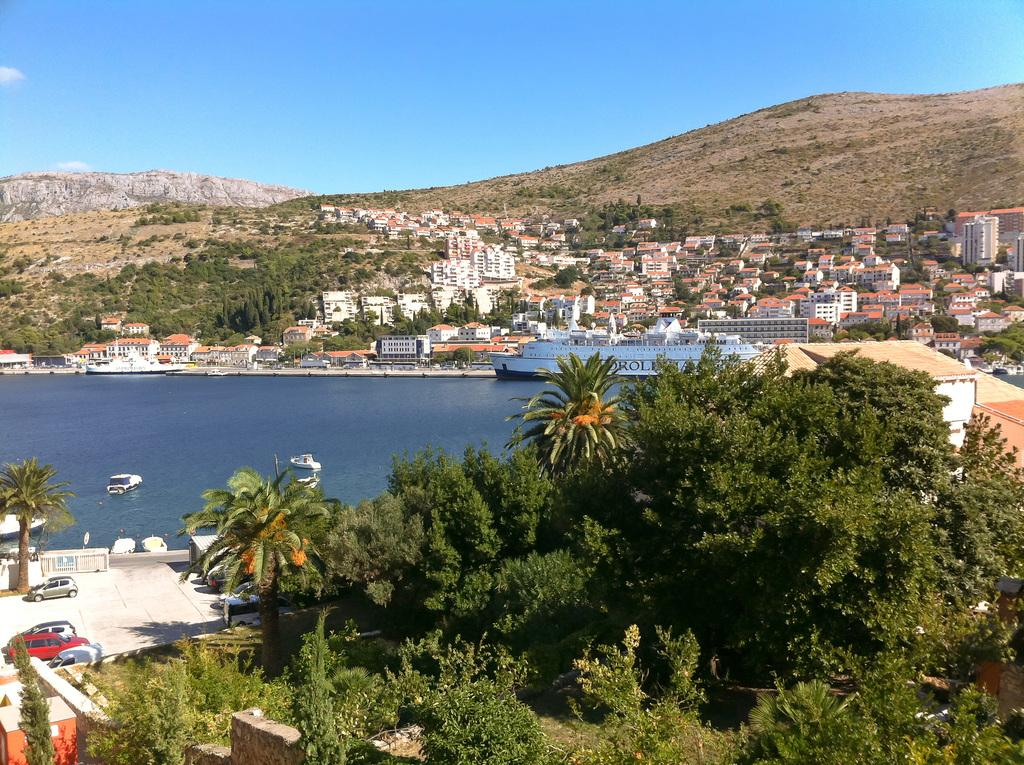What type of watercraft can be seen in the image? There is a ship and boats in the image. What is the primary setting of the image? There is water visible in the image, along with plants, trees, vehicles, buildings, and a mountain in the background. What is visible in the sky in the image? The sky is visible in the background of the image. How many crates of rabbits are being transported on the ship in the image? There are no crates of rabbits present in the image. What type of request is being made by the people on the boats in the image? There is no indication of any requests being made in the image. 